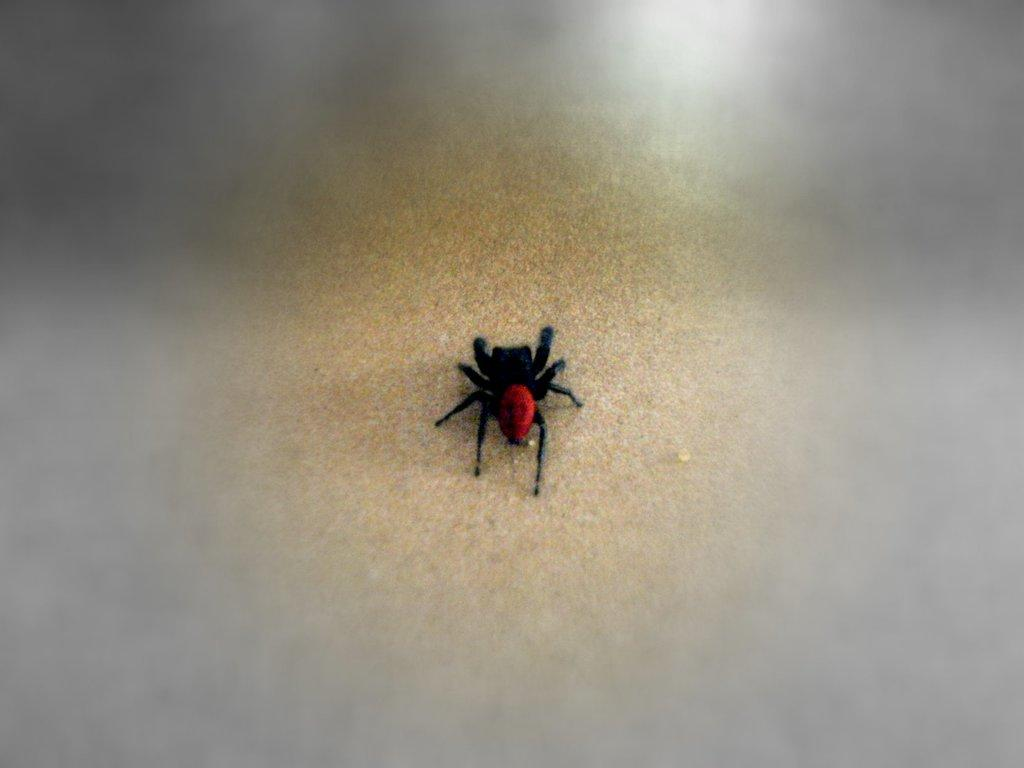What is the main subject of the image? The main subject of the image is a spider. Can you describe the appearance of the spider? The spider is black and red in color. What is the spider resting on in the image? The spider is on wood. What type of watch is the spider wearing on its neck in the image? There is no watch or neck present on the spider in the image; it is simply a black and red spider resting on wood. 